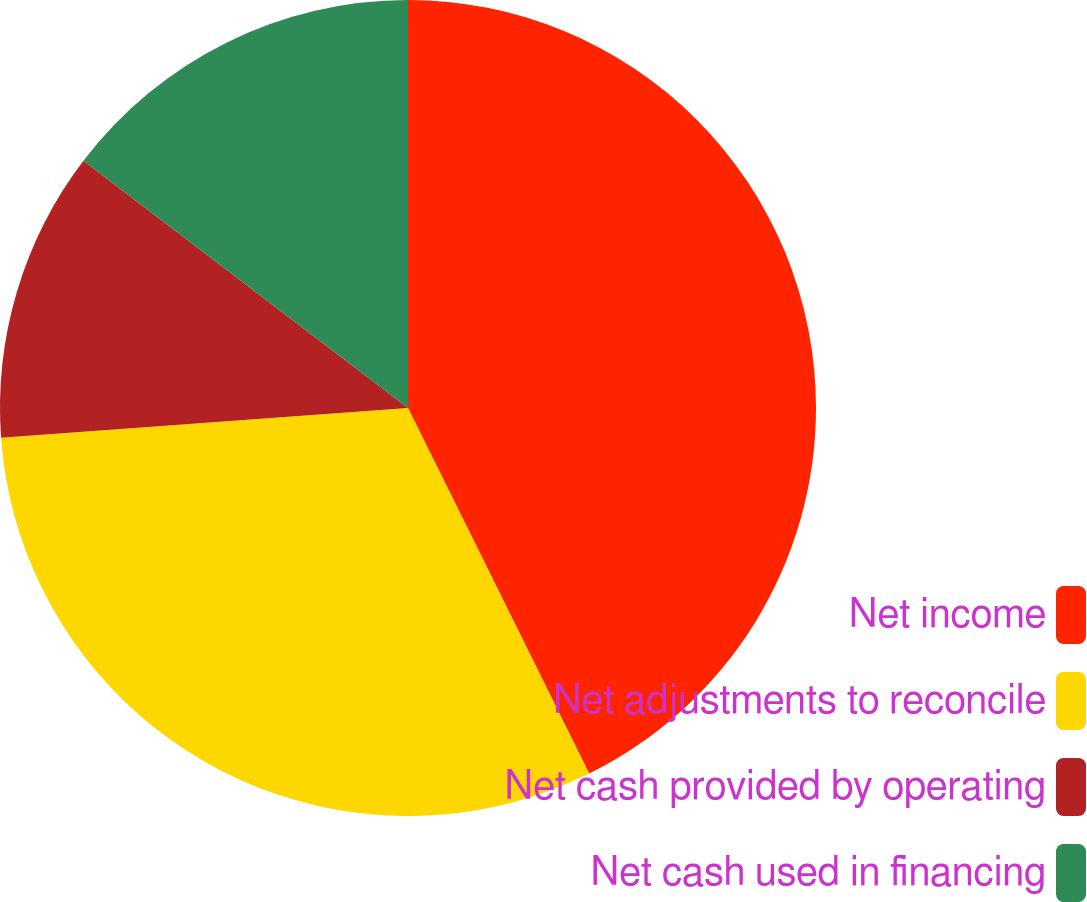<chart> <loc_0><loc_0><loc_500><loc_500><pie_chart><fcel>Net income<fcel>Net adjustments to reconcile<fcel>Net cash provided by operating<fcel>Net cash used in financing<nl><fcel>42.68%<fcel>31.16%<fcel>11.52%<fcel>14.64%<nl></chart> 